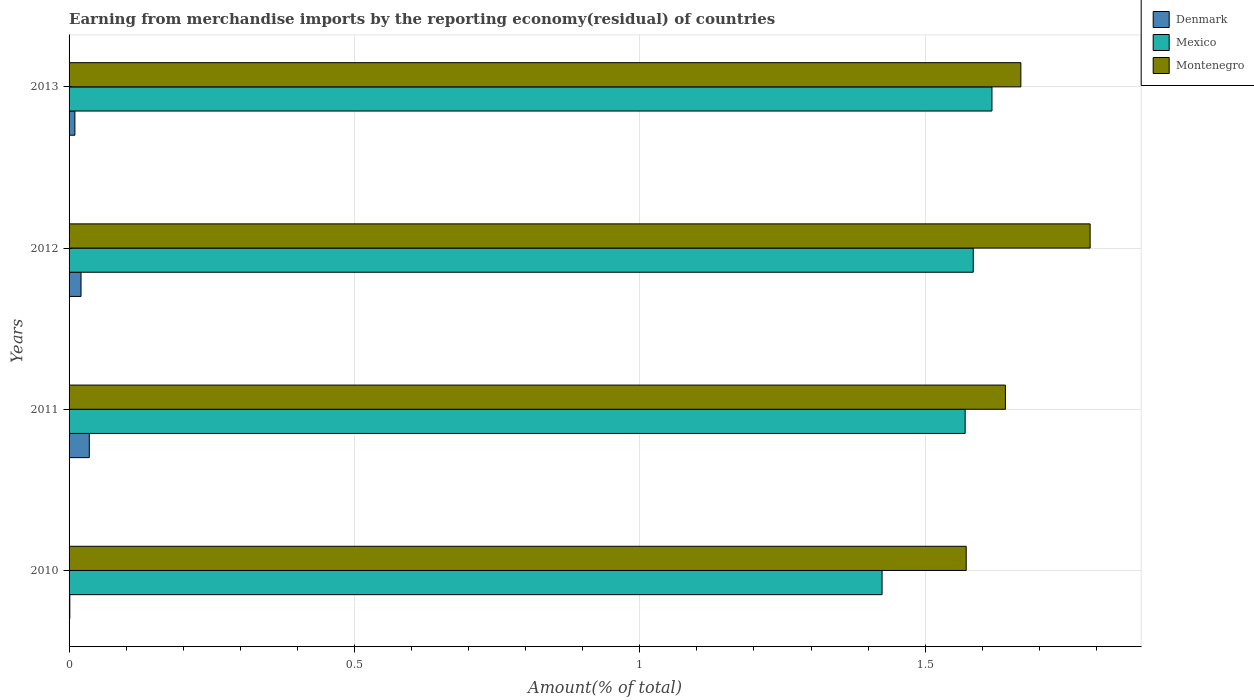How many different coloured bars are there?
Offer a very short reply. 3. How many groups of bars are there?
Your response must be concise. 4. Are the number of bars per tick equal to the number of legend labels?
Your response must be concise. Yes. Are the number of bars on each tick of the Y-axis equal?
Keep it short and to the point. Yes. How many bars are there on the 2nd tick from the bottom?
Offer a very short reply. 3. What is the percentage of amount earned from merchandise imports in Mexico in 2010?
Give a very brief answer. 1.42. Across all years, what is the maximum percentage of amount earned from merchandise imports in Denmark?
Offer a terse response. 0.04. Across all years, what is the minimum percentage of amount earned from merchandise imports in Mexico?
Give a very brief answer. 1.42. In which year was the percentage of amount earned from merchandise imports in Denmark minimum?
Your response must be concise. 2010. What is the total percentage of amount earned from merchandise imports in Mexico in the graph?
Provide a succinct answer. 6.2. What is the difference between the percentage of amount earned from merchandise imports in Montenegro in 2011 and that in 2013?
Your answer should be compact. -0.03. What is the difference between the percentage of amount earned from merchandise imports in Montenegro in 2010 and the percentage of amount earned from merchandise imports in Denmark in 2012?
Your response must be concise. 1.55. What is the average percentage of amount earned from merchandise imports in Mexico per year?
Make the answer very short. 1.55. In the year 2013, what is the difference between the percentage of amount earned from merchandise imports in Montenegro and percentage of amount earned from merchandise imports in Denmark?
Ensure brevity in your answer.  1.66. In how many years, is the percentage of amount earned from merchandise imports in Denmark greater than 0.4 %?
Offer a very short reply. 0. What is the ratio of the percentage of amount earned from merchandise imports in Mexico in 2011 to that in 2013?
Your answer should be very brief. 0.97. Is the difference between the percentage of amount earned from merchandise imports in Montenegro in 2010 and 2011 greater than the difference between the percentage of amount earned from merchandise imports in Denmark in 2010 and 2011?
Your response must be concise. No. What is the difference between the highest and the second highest percentage of amount earned from merchandise imports in Mexico?
Ensure brevity in your answer.  0.03. What is the difference between the highest and the lowest percentage of amount earned from merchandise imports in Denmark?
Offer a very short reply. 0.03. Is the sum of the percentage of amount earned from merchandise imports in Montenegro in 2011 and 2013 greater than the maximum percentage of amount earned from merchandise imports in Denmark across all years?
Provide a short and direct response. Yes. What does the 2nd bar from the top in 2011 represents?
Your response must be concise. Mexico. What does the 3rd bar from the bottom in 2011 represents?
Offer a terse response. Montenegro. Is it the case that in every year, the sum of the percentage of amount earned from merchandise imports in Denmark and percentage of amount earned from merchandise imports in Montenegro is greater than the percentage of amount earned from merchandise imports in Mexico?
Provide a succinct answer. Yes. What is the difference between two consecutive major ticks on the X-axis?
Provide a succinct answer. 0.5. Does the graph contain any zero values?
Give a very brief answer. No. How many legend labels are there?
Keep it short and to the point. 3. What is the title of the graph?
Your answer should be compact. Earning from merchandise imports by the reporting economy(residual) of countries. Does "Djibouti" appear as one of the legend labels in the graph?
Your answer should be very brief. No. What is the label or title of the X-axis?
Ensure brevity in your answer.  Amount(% of total). What is the Amount(% of total) of Denmark in 2010?
Keep it short and to the point. 0. What is the Amount(% of total) of Mexico in 2010?
Give a very brief answer. 1.42. What is the Amount(% of total) in Montenegro in 2010?
Your response must be concise. 1.57. What is the Amount(% of total) in Denmark in 2011?
Provide a short and direct response. 0.04. What is the Amount(% of total) of Mexico in 2011?
Provide a short and direct response. 1.57. What is the Amount(% of total) in Montenegro in 2011?
Offer a terse response. 1.64. What is the Amount(% of total) in Denmark in 2012?
Keep it short and to the point. 0.02. What is the Amount(% of total) of Mexico in 2012?
Make the answer very short. 1.58. What is the Amount(% of total) of Montenegro in 2012?
Your response must be concise. 1.79. What is the Amount(% of total) in Denmark in 2013?
Offer a very short reply. 0.01. What is the Amount(% of total) of Mexico in 2013?
Keep it short and to the point. 1.62. What is the Amount(% of total) of Montenegro in 2013?
Your response must be concise. 1.67. Across all years, what is the maximum Amount(% of total) in Denmark?
Your answer should be compact. 0.04. Across all years, what is the maximum Amount(% of total) in Mexico?
Give a very brief answer. 1.62. Across all years, what is the maximum Amount(% of total) of Montenegro?
Give a very brief answer. 1.79. Across all years, what is the minimum Amount(% of total) of Denmark?
Your answer should be very brief. 0. Across all years, what is the minimum Amount(% of total) of Mexico?
Your answer should be very brief. 1.42. Across all years, what is the minimum Amount(% of total) in Montenegro?
Make the answer very short. 1.57. What is the total Amount(% of total) of Denmark in the graph?
Keep it short and to the point. 0.07. What is the total Amount(% of total) in Mexico in the graph?
Offer a terse response. 6.2. What is the total Amount(% of total) of Montenegro in the graph?
Keep it short and to the point. 6.67. What is the difference between the Amount(% of total) in Denmark in 2010 and that in 2011?
Your response must be concise. -0.03. What is the difference between the Amount(% of total) of Mexico in 2010 and that in 2011?
Keep it short and to the point. -0.15. What is the difference between the Amount(% of total) in Montenegro in 2010 and that in 2011?
Make the answer very short. -0.07. What is the difference between the Amount(% of total) of Denmark in 2010 and that in 2012?
Offer a terse response. -0.02. What is the difference between the Amount(% of total) of Mexico in 2010 and that in 2012?
Offer a terse response. -0.16. What is the difference between the Amount(% of total) of Montenegro in 2010 and that in 2012?
Your response must be concise. -0.22. What is the difference between the Amount(% of total) in Denmark in 2010 and that in 2013?
Keep it short and to the point. -0.01. What is the difference between the Amount(% of total) of Mexico in 2010 and that in 2013?
Your response must be concise. -0.19. What is the difference between the Amount(% of total) of Montenegro in 2010 and that in 2013?
Provide a succinct answer. -0.1. What is the difference between the Amount(% of total) of Denmark in 2011 and that in 2012?
Make the answer very short. 0.01. What is the difference between the Amount(% of total) in Mexico in 2011 and that in 2012?
Provide a succinct answer. -0.01. What is the difference between the Amount(% of total) in Montenegro in 2011 and that in 2012?
Give a very brief answer. -0.15. What is the difference between the Amount(% of total) in Denmark in 2011 and that in 2013?
Keep it short and to the point. 0.03. What is the difference between the Amount(% of total) of Mexico in 2011 and that in 2013?
Your response must be concise. -0.05. What is the difference between the Amount(% of total) in Montenegro in 2011 and that in 2013?
Keep it short and to the point. -0.03. What is the difference between the Amount(% of total) in Denmark in 2012 and that in 2013?
Offer a very short reply. 0.01. What is the difference between the Amount(% of total) in Mexico in 2012 and that in 2013?
Keep it short and to the point. -0.03. What is the difference between the Amount(% of total) in Montenegro in 2012 and that in 2013?
Keep it short and to the point. 0.12. What is the difference between the Amount(% of total) of Denmark in 2010 and the Amount(% of total) of Mexico in 2011?
Your answer should be very brief. -1.57. What is the difference between the Amount(% of total) in Denmark in 2010 and the Amount(% of total) in Montenegro in 2011?
Offer a terse response. -1.64. What is the difference between the Amount(% of total) in Mexico in 2010 and the Amount(% of total) in Montenegro in 2011?
Offer a terse response. -0.22. What is the difference between the Amount(% of total) of Denmark in 2010 and the Amount(% of total) of Mexico in 2012?
Your response must be concise. -1.58. What is the difference between the Amount(% of total) of Denmark in 2010 and the Amount(% of total) of Montenegro in 2012?
Ensure brevity in your answer.  -1.79. What is the difference between the Amount(% of total) of Mexico in 2010 and the Amount(% of total) of Montenegro in 2012?
Ensure brevity in your answer.  -0.36. What is the difference between the Amount(% of total) of Denmark in 2010 and the Amount(% of total) of Mexico in 2013?
Your response must be concise. -1.62. What is the difference between the Amount(% of total) of Denmark in 2010 and the Amount(% of total) of Montenegro in 2013?
Your answer should be compact. -1.67. What is the difference between the Amount(% of total) in Mexico in 2010 and the Amount(% of total) in Montenegro in 2013?
Make the answer very short. -0.24. What is the difference between the Amount(% of total) of Denmark in 2011 and the Amount(% of total) of Mexico in 2012?
Give a very brief answer. -1.55. What is the difference between the Amount(% of total) in Denmark in 2011 and the Amount(% of total) in Montenegro in 2012?
Your answer should be compact. -1.75. What is the difference between the Amount(% of total) of Mexico in 2011 and the Amount(% of total) of Montenegro in 2012?
Make the answer very short. -0.22. What is the difference between the Amount(% of total) in Denmark in 2011 and the Amount(% of total) in Mexico in 2013?
Provide a short and direct response. -1.58. What is the difference between the Amount(% of total) of Denmark in 2011 and the Amount(% of total) of Montenegro in 2013?
Give a very brief answer. -1.63. What is the difference between the Amount(% of total) of Mexico in 2011 and the Amount(% of total) of Montenegro in 2013?
Keep it short and to the point. -0.1. What is the difference between the Amount(% of total) in Denmark in 2012 and the Amount(% of total) in Mexico in 2013?
Your answer should be compact. -1.6. What is the difference between the Amount(% of total) of Denmark in 2012 and the Amount(% of total) of Montenegro in 2013?
Ensure brevity in your answer.  -1.65. What is the difference between the Amount(% of total) of Mexico in 2012 and the Amount(% of total) of Montenegro in 2013?
Your answer should be very brief. -0.08. What is the average Amount(% of total) of Denmark per year?
Make the answer very short. 0.02. What is the average Amount(% of total) in Mexico per year?
Offer a very short reply. 1.55. What is the average Amount(% of total) of Montenegro per year?
Your answer should be compact. 1.67. In the year 2010, what is the difference between the Amount(% of total) in Denmark and Amount(% of total) in Mexico?
Make the answer very short. -1.42. In the year 2010, what is the difference between the Amount(% of total) in Denmark and Amount(% of total) in Montenegro?
Give a very brief answer. -1.57. In the year 2010, what is the difference between the Amount(% of total) of Mexico and Amount(% of total) of Montenegro?
Keep it short and to the point. -0.15. In the year 2011, what is the difference between the Amount(% of total) of Denmark and Amount(% of total) of Mexico?
Your answer should be compact. -1.53. In the year 2011, what is the difference between the Amount(% of total) in Denmark and Amount(% of total) in Montenegro?
Your answer should be very brief. -1.61. In the year 2011, what is the difference between the Amount(% of total) of Mexico and Amount(% of total) of Montenegro?
Make the answer very short. -0.07. In the year 2012, what is the difference between the Amount(% of total) in Denmark and Amount(% of total) in Mexico?
Provide a succinct answer. -1.56. In the year 2012, what is the difference between the Amount(% of total) of Denmark and Amount(% of total) of Montenegro?
Offer a terse response. -1.77. In the year 2012, what is the difference between the Amount(% of total) of Mexico and Amount(% of total) of Montenegro?
Your answer should be very brief. -0.2. In the year 2013, what is the difference between the Amount(% of total) in Denmark and Amount(% of total) in Mexico?
Ensure brevity in your answer.  -1.61. In the year 2013, what is the difference between the Amount(% of total) in Denmark and Amount(% of total) in Montenegro?
Ensure brevity in your answer.  -1.66. In the year 2013, what is the difference between the Amount(% of total) of Mexico and Amount(% of total) of Montenegro?
Give a very brief answer. -0.05. What is the ratio of the Amount(% of total) of Denmark in 2010 to that in 2011?
Provide a succinct answer. 0.04. What is the ratio of the Amount(% of total) in Mexico in 2010 to that in 2011?
Give a very brief answer. 0.91. What is the ratio of the Amount(% of total) of Montenegro in 2010 to that in 2011?
Your response must be concise. 0.96. What is the ratio of the Amount(% of total) of Denmark in 2010 to that in 2012?
Your answer should be compact. 0.06. What is the ratio of the Amount(% of total) of Mexico in 2010 to that in 2012?
Your answer should be very brief. 0.9. What is the ratio of the Amount(% of total) in Montenegro in 2010 to that in 2012?
Your response must be concise. 0.88. What is the ratio of the Amount(% of total) in Denmark in 2010 to that in 2013?
Provide a short and direct response. 0.13. What is the ratio of the Amount(% of total) in Mexico in 2010 to that in 2013?
Keep it short and to the point. 0.88. What is the ratio of the Amount(% of total) of Montenegro in 2010 to that in 2013?
Make the answer very short. 0.94. What is the ratio of the Amount(% of total) in Denmark in 2011 to that in 2012?
Make the answer very short. 1.69. What is the ratio of the Amount(% of total) of Montenegro in 2011 to that in 2012?
Your answer should be very brief. 0.92. What is the ratio of the Amount(% of total) of Denmark in 2011 to that in 2013?
Provide a succinct answer. 3.47. What is the ratio of the Amount(% of total) of Mexico in 2011 to that in 2013?
Ensure brevity in your answer.  0.97. What is the ratio of the Amount(% of total) in Montenegro in 2011 to that in 2013?
Offer a very short reply. 0.98. What is the ratio of the Amount(% of total) in Denmark in 2012 to that in 2013?
Keep it short and to the point. 2.05. What is the ratio of the Amount(% of total) in Mexico in 2012 to that in 2013?
Make the answer very short. 0.98. What is the ratio of the Amount(% of total) of Montenegro in 2012 to that in 2013?
Provide a short and direct response. 1.07. What is the difference between the highest and the second highest Amount(% of total) of Denmark?
Provide a succinct answer. 0.01. What is the difference between the highest and the second highest Amount(% of total) in Mexico?
Provide a short and direct response. 0.03. What is the difference between the highest and the second highest Amount(% of total) of Montenegro?
Offer a terse response. 0.12. What is the difference between the highest and the lowest Amount(% of total) in Denmark?
Make the answer very short. 0.03. What is the difference between the highest and the lowest Amount(% of total) of Mexico?
Offer a terse response. 0.19. What is the difference between the highest and the lowest Amount(% of total) of Montenegro?
Offer a very short reply. 0.22. 